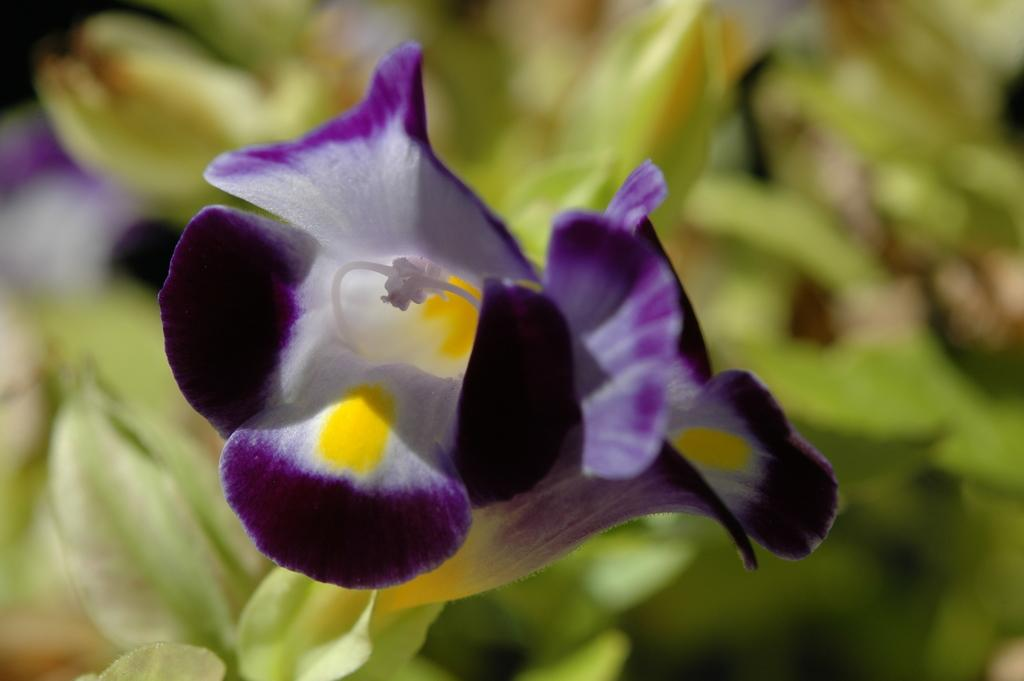What is the main subject of the image? The main subject of the image is a flower. Can you describe the colors of the flower's petals? The flower's petals are in white and violet colors. What else can be seen in the background of the image? There are leaves visible in the background of the image. How does the flower compare to the size of the bridge in the image? There is no bridge present in the image, so it is not possible to make a comparison. 